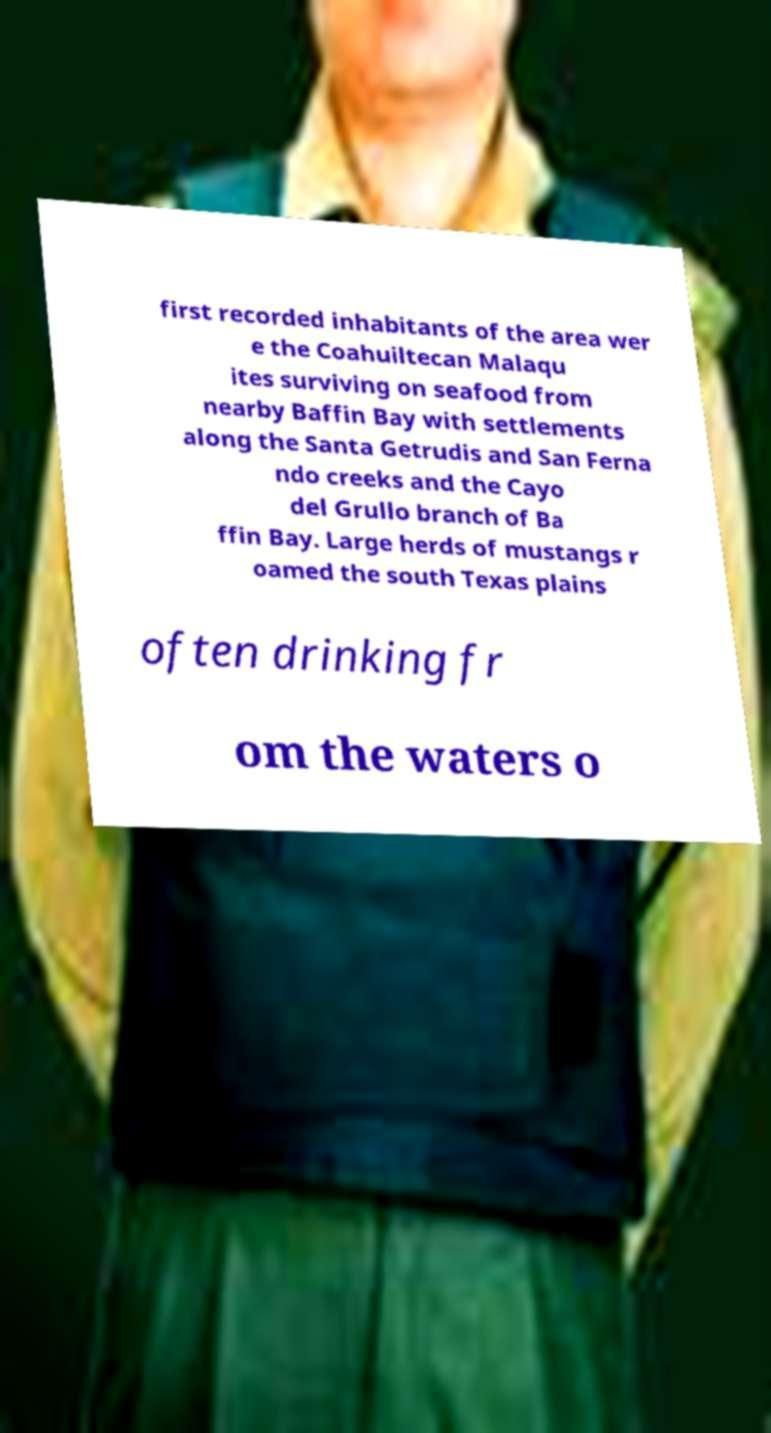For documentation purposes, I need the text within this image transcribed. Could you provide that? first recorded inhabitants of the area wer e the Coahuiltecan Malaqu ites surviving on seafood from nearby Baffin Bay with settlements along the Santa Getrudis and San Ferna ndo creeks and the Cayo del Grullo branch of Ba ffin Bay. Large herds of mustangs r oamed the south Texas plains often drinking fr om the waters o 